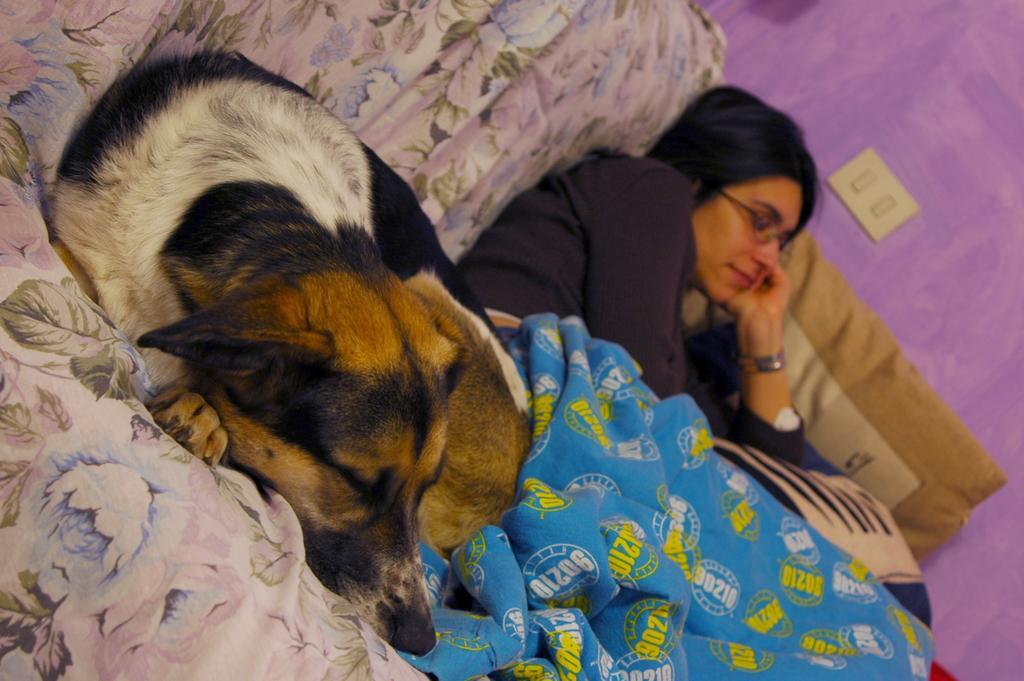In one or two sentences, can you explain what this image depicts? In this image there is a lady person and a dog who are sleeping on the couch. 